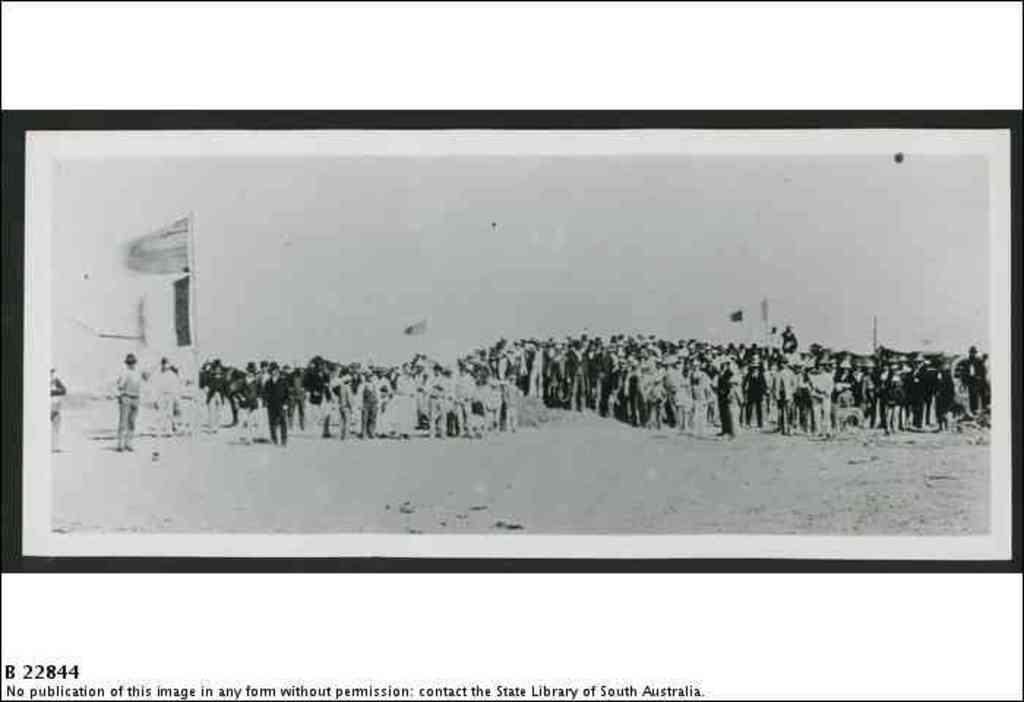Provide a one-sentence caption for the provided image. An old black and white photo of a large group of people with a note underneath that the photo can not be published. 